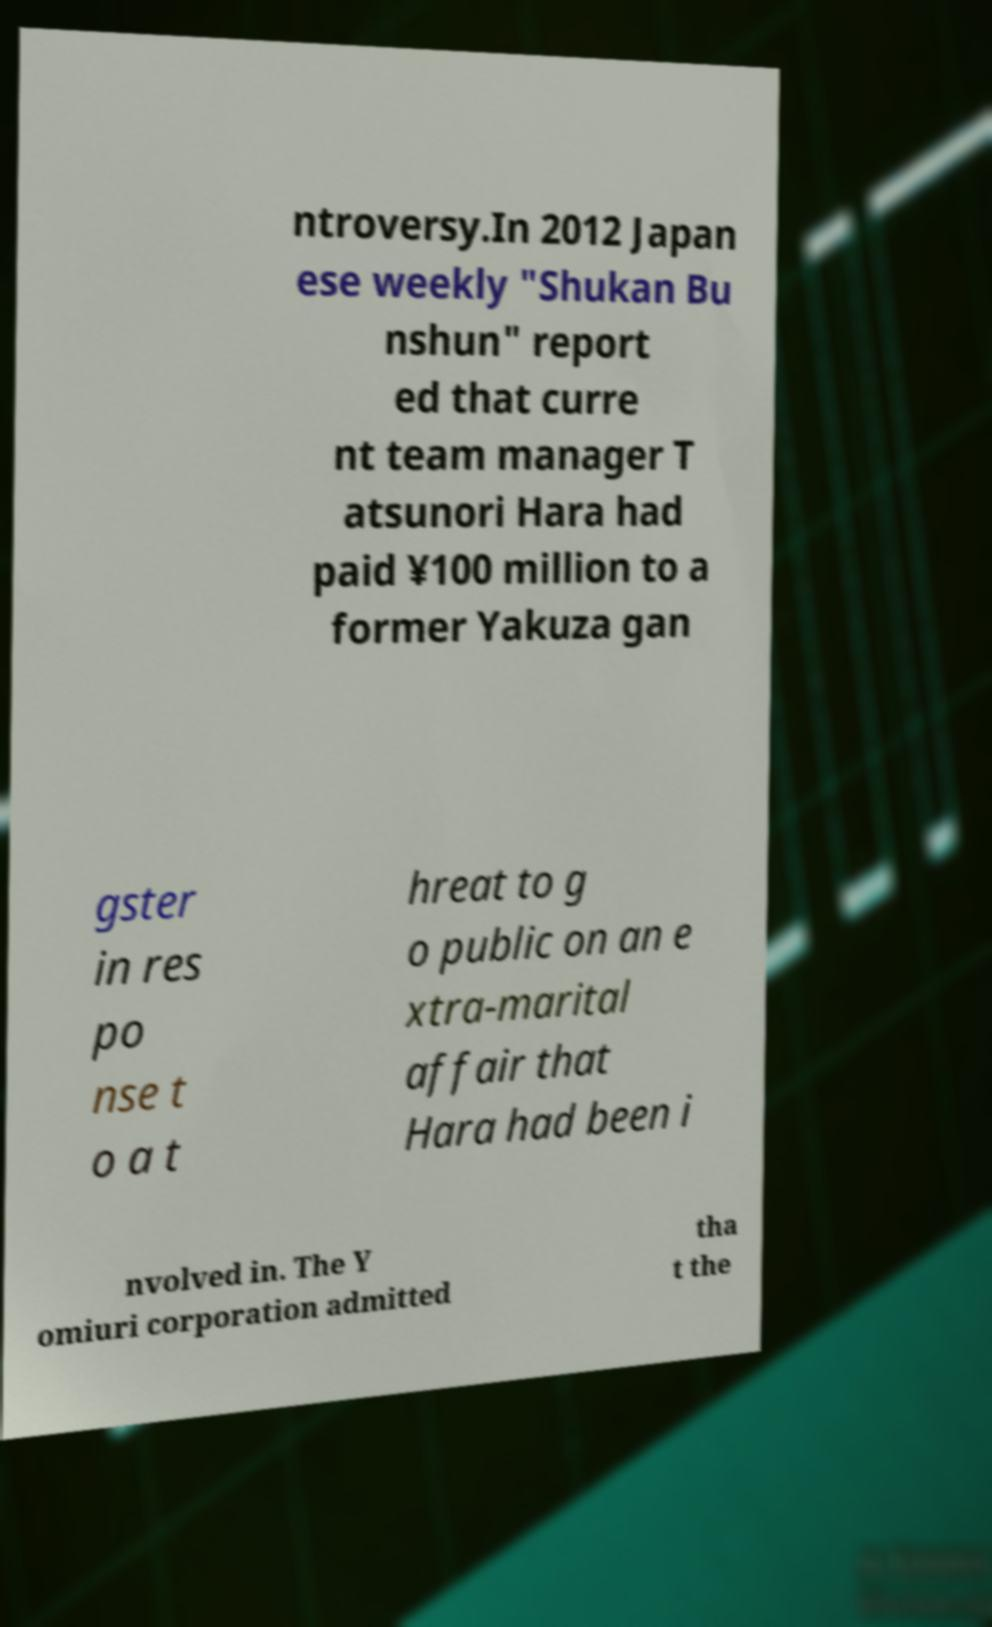I need the written content from this picture converted into text. Can you do that? ntroversy.In 2012 Japan ese weekly "Shukan Bu nshun" report ed that curre nt team manager T atsunori Hara had paid ¥100 million to a former Yakuza gan gster in res po nse t o a t hreat to g o public on an e xtra-marital affair that Hara had been i nvolved in. The Y omiuri corporation admitted tha t the 